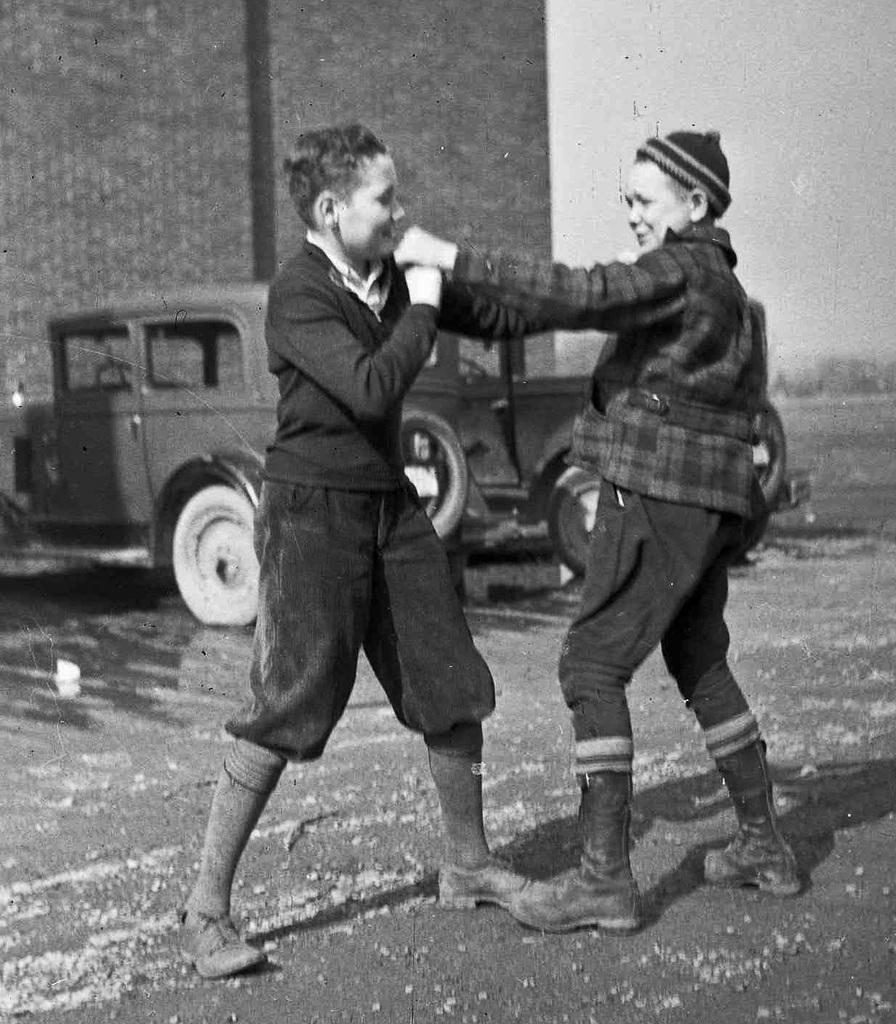How many people are in the image? There are two persons standing in the middle of the image. What are the people doing in the image? The persons are smiling. What can be seen behind the people in the image? There are vehicles visible behind the persons. What is at the top of the image? There is a wall at the top of the image. What type of sand can be seen on the floor in the image? There is no sand visible on the floor in the image. 